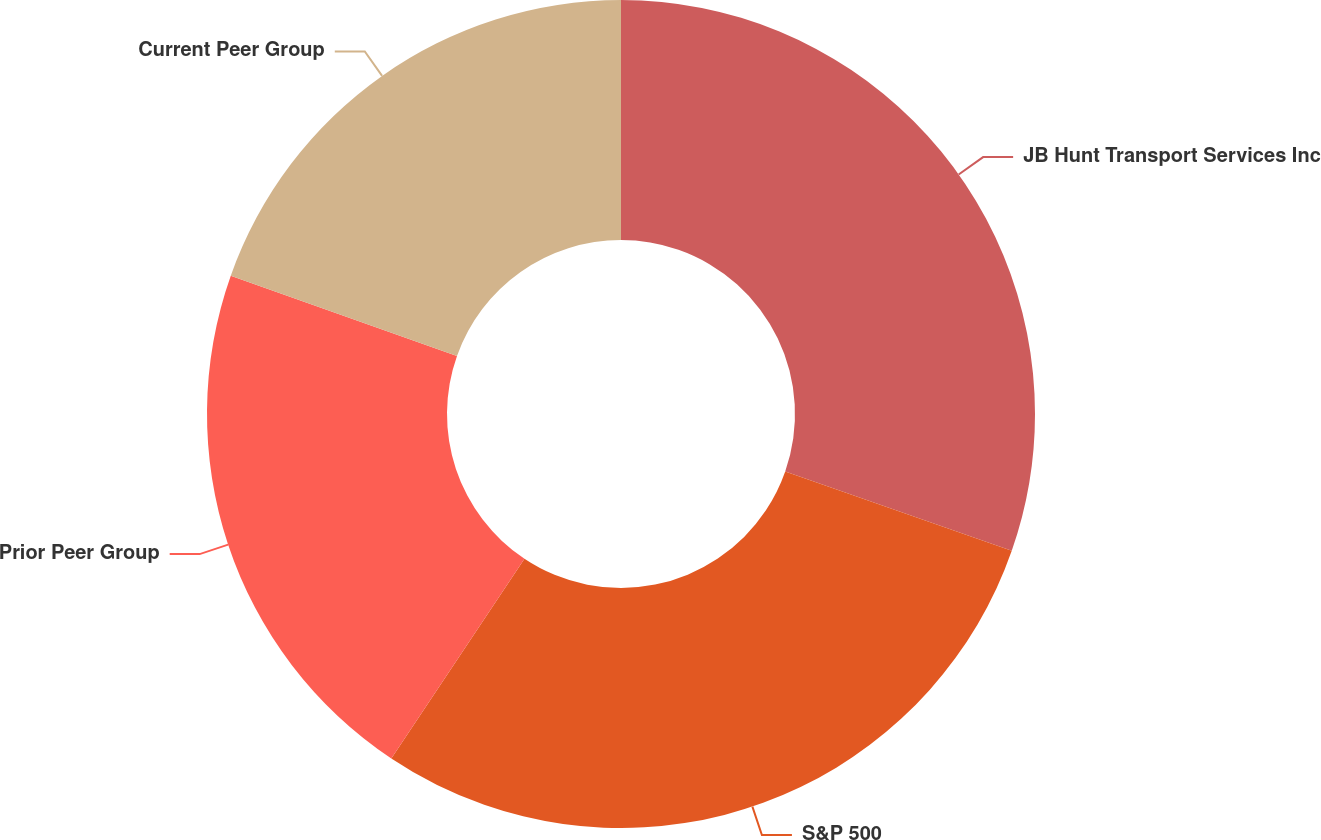<chart> <loc_0><loc_0><loc_500><loc_500><pie_chart><fcel>JB Hunt Transport Services Inc<fcel>S&P 500<fcel>Prior Peer Group<fcel>Current Peer Group<nl><fcel>30.36%<fcel>29.0%<fcel>21.06%<fcel>19.58%<nl></chart> 